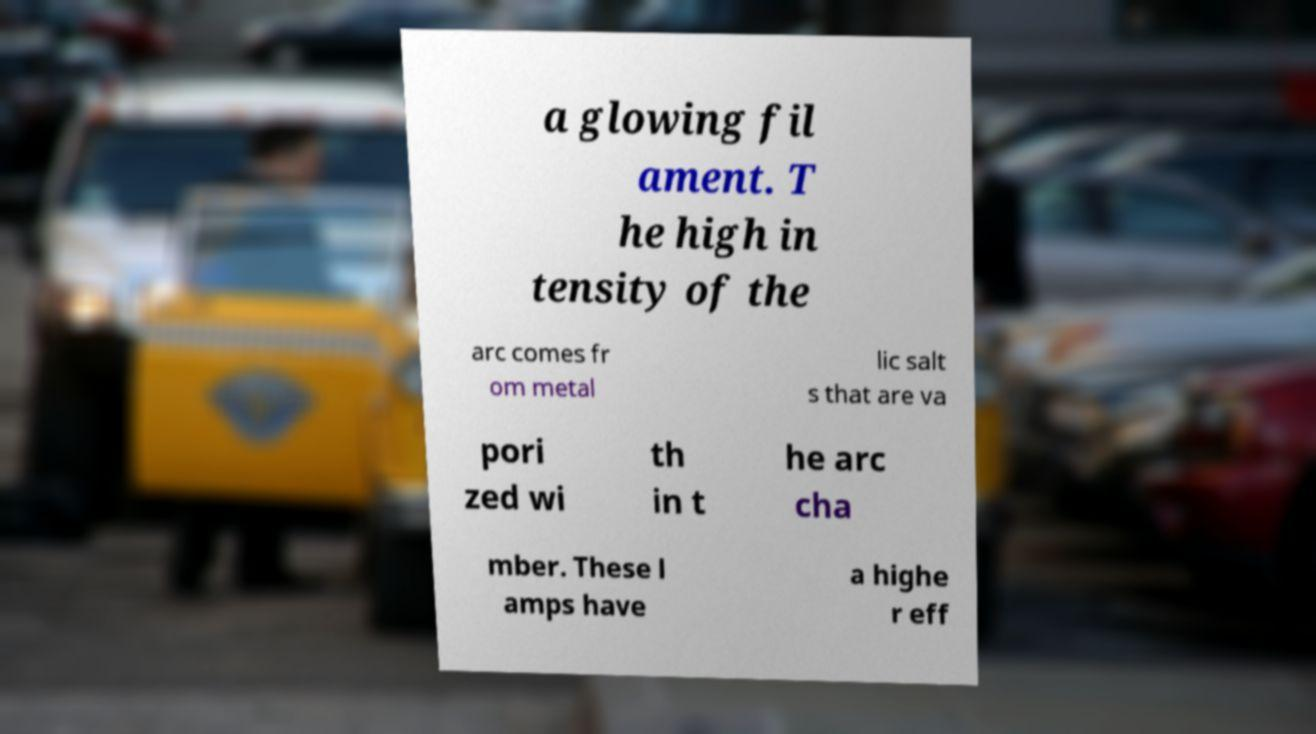Could you assist in decoding the text presented in this image and type it out clearly? a glowing fil ament. T he high in tensity of the arc comes fr om metal lic salt s that are va pori zed wi th in t he arc cha mber. These l amps have a highe r eff 